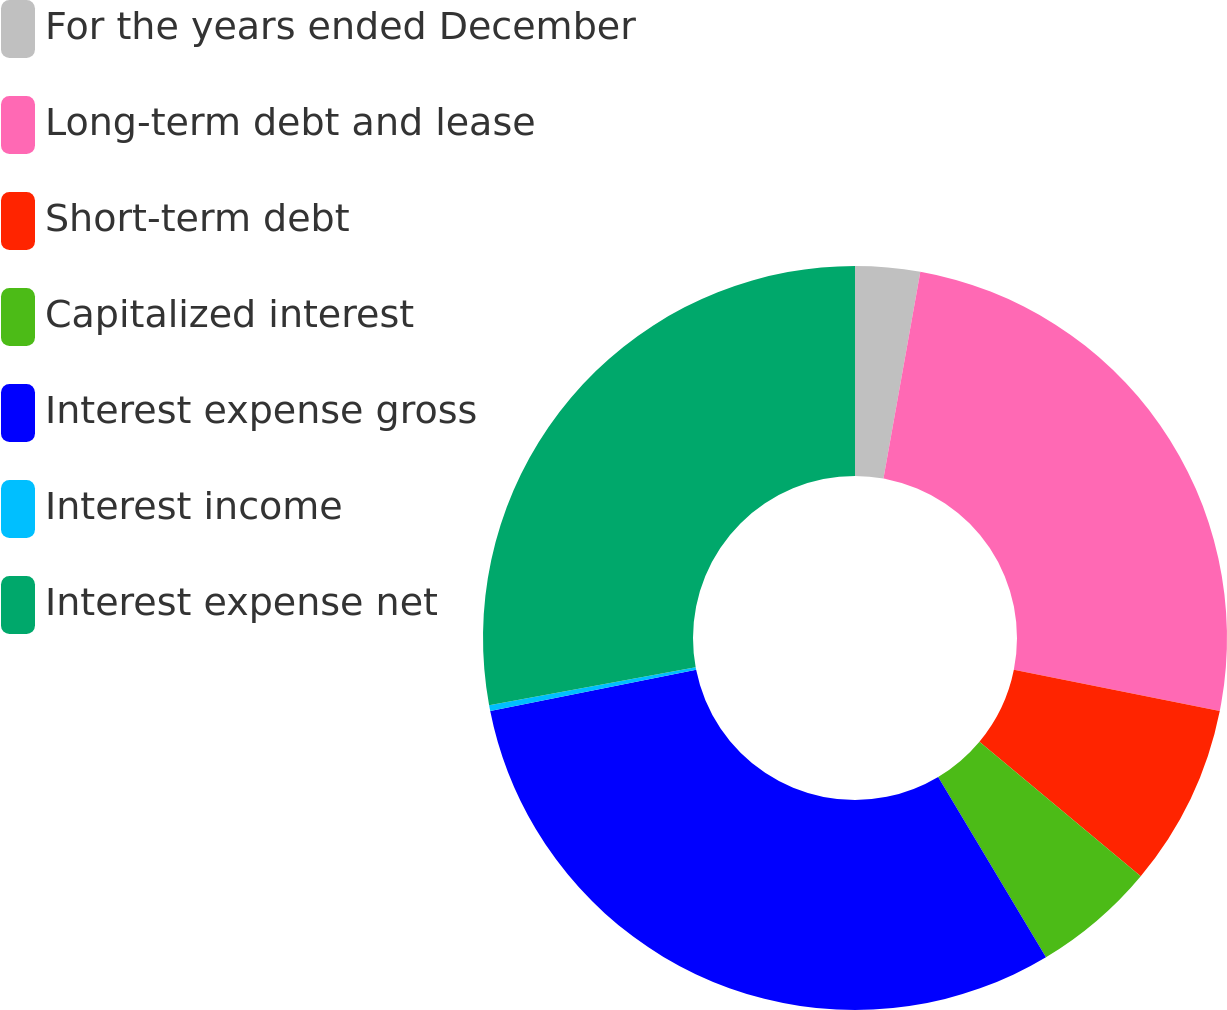Convert chart. <chart><loc_0><loc_0><loc_500><loc_500><pie_chart><fcel>For the years ended December<fcel>Long-term debt and lease<fcel>Short-term debt<fcel>Capitalized interest<fcel>Interest expense gross<fcel>Interest income<fcel>Interest expense net<nl><fcel>2.81%<fcel>25.33%<fcel>7.92%<fcel>5.36%<fcel>30.44%<fcel>0.25%<fcel>27.89%<nl></chart> 